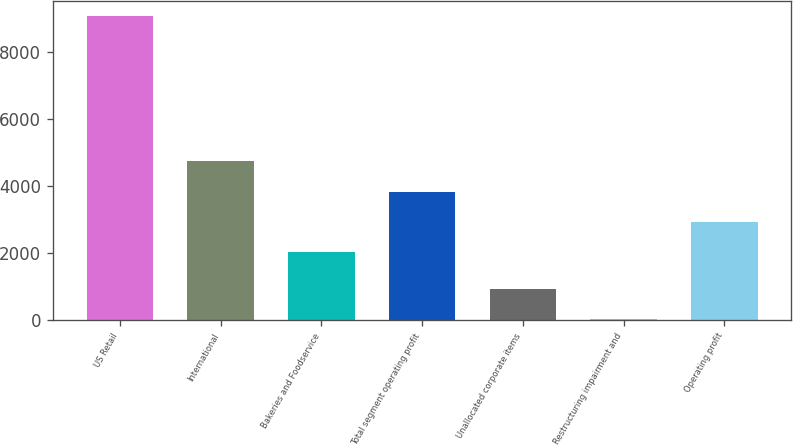<chart> <loc_0><loc_0><loc_500><loc_500><bar_chart><fcel>US Retail<fcel>International<fcel>Bakeries and Foodservice<fcel>Total segment operating profit<fcel>Unallocated corporate items<fcel>Restructuring impairment and<fcel>Operating profit<nl><fcel>9072<fcel>4736.6<fcel>2021.3<fcel>3831.5<fcel>926.1<fcel>21<fcel>2926.4<nl></chart> 